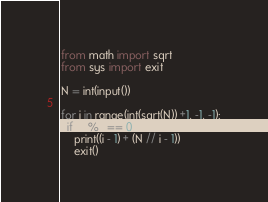<code> <loc_0><loc_0><loc_500><loc_500><_Python_>from math import sqrt
from sys import exit

N = int(input())

for i in range(int(sqrt(N)) +1, -1, -1):
  if N % i == 0:
    print((i - 1) + (N // i - 1))
    exit()</code> 